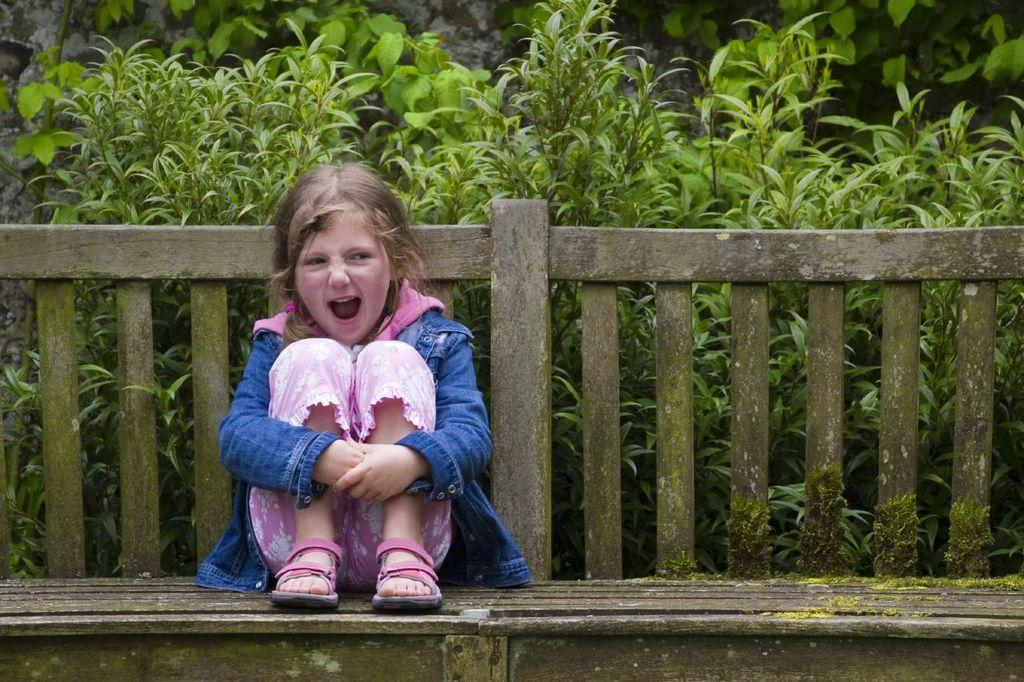Who is the main subject in the image? There is a girl in the image. What is the girl doing in the image? The girl is sitting on a chair. What is the girl wearing in the image? The girl is wearing a pink dress and footwear. What can be seen behind the girl in the image? There are plants behind the girl. What type of pie is the girl holding in the image? There is no pie present in the image; the girl is wearing a pink dress and sitting on a chair. 